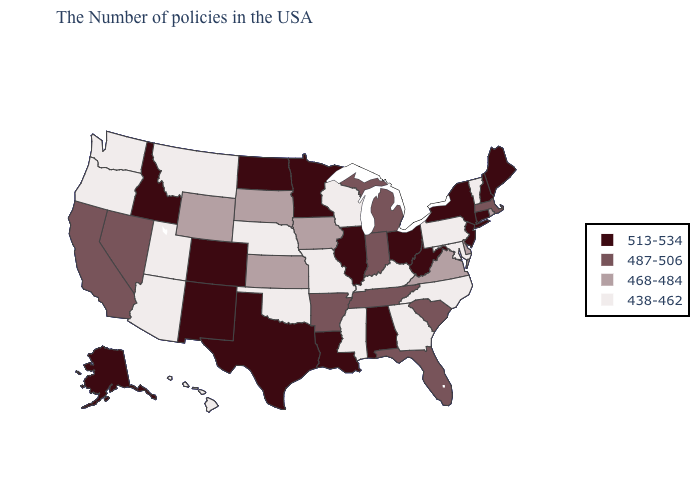What is the value of New Mexico?
Quick response, please. 513-534. Does the map have missing data?
Give a very brief answer. No. What is the value of Maryland?
Give a very brief answer. 438-462. Among the states that border Mississippi , which have the lowest value?
Keep it brief. Tennessee, Arkansas. Does Mississippi have the highest value in the South?
Short answer required. No. Name the states that have a value in the range 487-506?
Give a very brief answer. Massachusetts, South Carolina, Florida, Michigan, Indiana, Tennessee, Arkansas, Nevada, California. Name the states that have a value in the range 513-534?
Concise answer only. Maine, New Hampshire, Connecticut, New York, New Jersey, West Virginia, Ohio, Alabama, Illinois, Louisiana, Minnesota, Texas, North Dakota, Colorado, New Mexico, Idaho, Alaska. What is the value of Utah?
Be succinct. 438-462. Which states have the lowest value in the MidWest?
Write a very short answer. Wisconsin, Missouri, Nebraska. Does Florida have a higher value than New York?
Write a very short answer. No. Name the states that have a value in the range 438-462?
Concise answer only. Vermont, Maryland, Pennsylvania, North Carolina, Georgia, Kentucky, Wisconsin, Mississippi, Missouri, Nebraska, Oklahoma, Utah, Montana, Arizona, Washington, Oregon, Hawaii. Which states hav the highest value in the MidWest?
Short answer required. Ohio, Illinois, Minnesota, North Dakota. Name the states that have a value in the range 513-534?
Be succinct. Maine, New Hampshire, Connecticut, New York, New Jersey, West Virginia, Ohio, Alabama, Illinois, Louisiana, Minnesota, Texas, North Dakota, Colorado, New Mexico, Idaho, Alaska. Does North Dakota have a lower value than Delaware?
Keep it brief. No. 